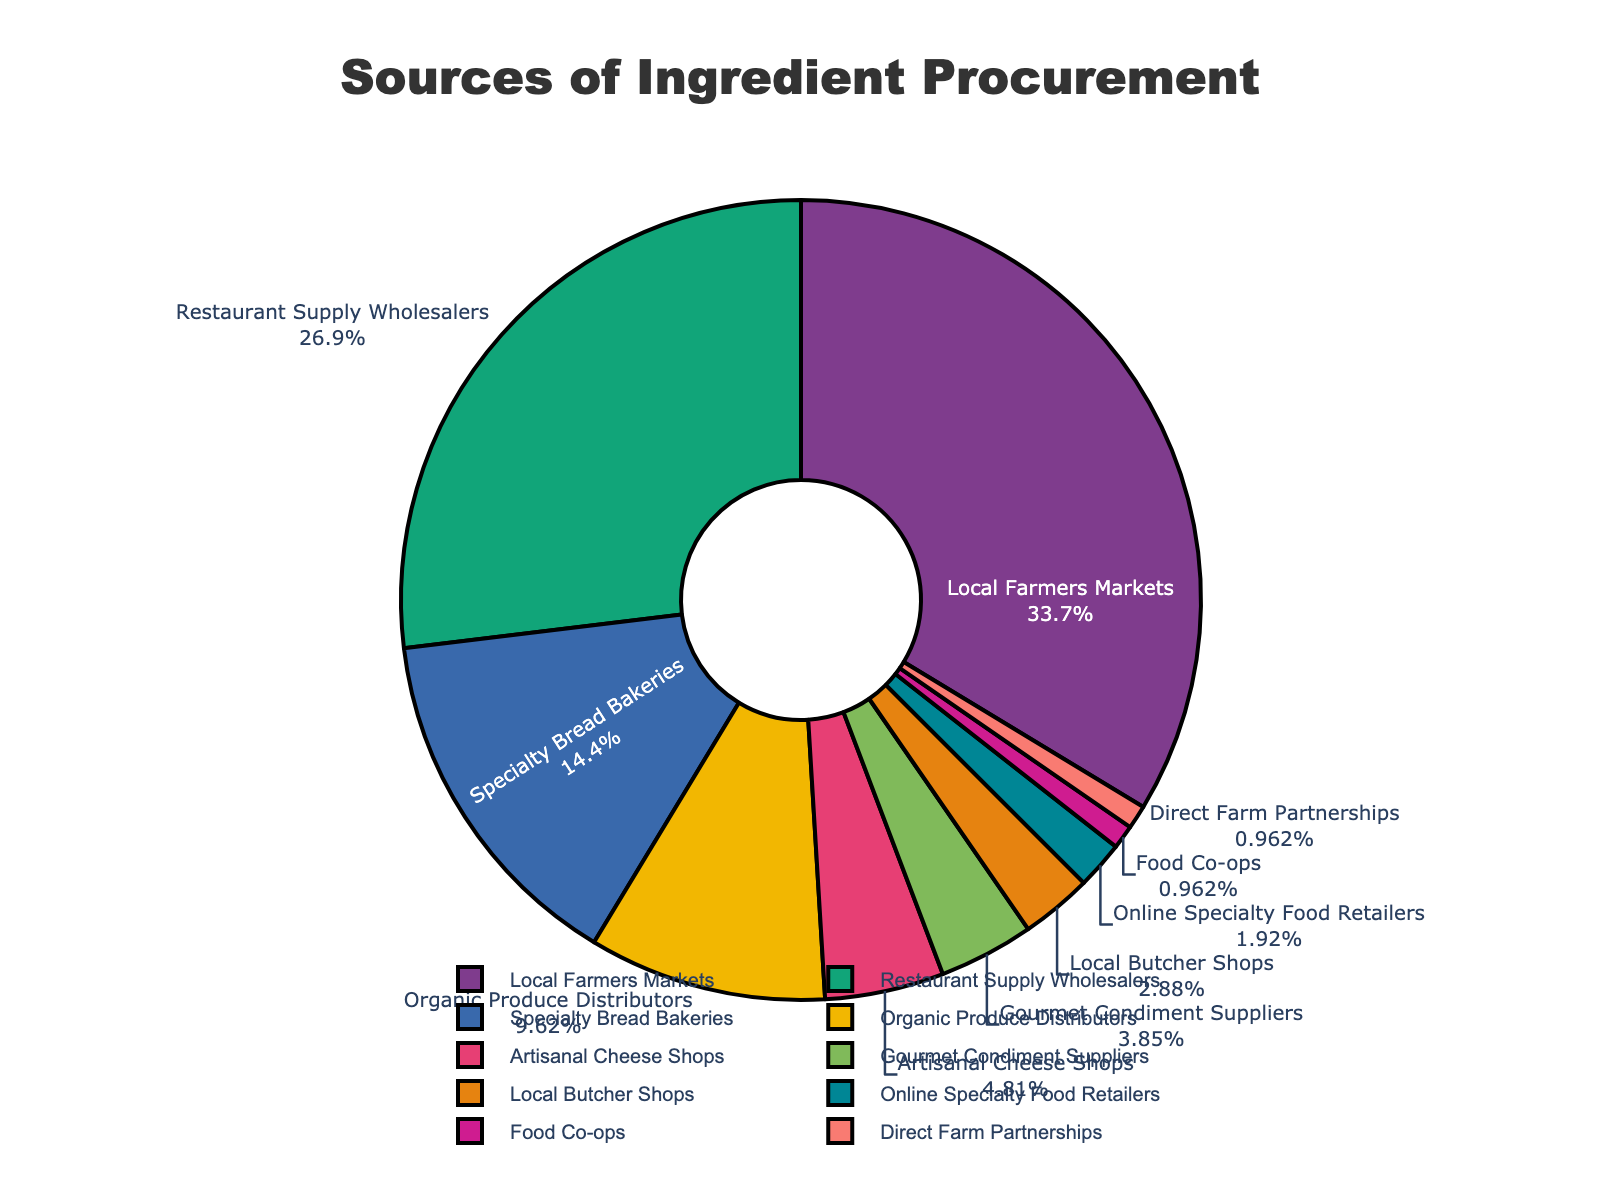Which supplier category provides the highest percentage of ingredients? By observing the size of the slices in the pie chart, the largest slice represents the supplier category with the highest percentage. The "Local Farmers Markets" category takes up the largest portion of the pie chart.
Answer: Local Farmers Markets What percentage of ingredients comes from Restaurant Supply Wholesalers and Specialty Bread Bakeries combined? Add the values associated with "Restaurant Supply Wholesalers" and "Specialty Bread Bakeries" in the figure: 28% (Restaurant Supply Wholesalers) + 15% (Specialty Bread Bakeries) = 43%.
Answer: 43% How does the percentage from Organic Produce Distributors compare to that from Artisanal Cheese Shops? Compare the values from the figure for "Organic Produce Distributors" (10%) and "Artisanal Cheese Shops" (5%). Organic Produce Distributors have a higher percentage.
Answer: 10% is higher than 5% Which supplier category provides the smallest percentage of ingredients? Look for the smallest slice in the pie chart. The segment labeled "Direct Farm Partnerships" and "Food Co-ops" are tied for the smallest share, each with 1%.
Answer: Direct Farm Partnerships and Food Co-ops What is the combined percentage of ingredients from Gourmet Condiment Suppliers, Local Butcher Shops, and Online Specialty Food Retailers? Sum the values associated with "Gourmet Condiment Suppliers" (4%), "Local Butcher Shops" (3%), and "Online Specialty Food Retailers" (2%): 4% + 3% + 2% = 9%.
Answer: 9% How much larger is the percentage from Local Farmers Markets compared to that from Organic Produce Distributors? Subtract the percentage of Organic Produce Distributors (10%) from the percentage of Local Farmers Markets (35%): 35% - 10% = 25%.
Answer: 25% What is the average percentage contribution of the top three supplier categories? The top three categories are "Local Farmers Markets" (35%), "Restaurant Supply Wholesalers" (28%), and "Specialty Bread Bakeries" (15%). Calculate the average: (35% + 28% + 15%) / 3 = 26%.
Answer: 26% Which category shows a percentage closest to 5%? The "Artisanal Cheese Shops" category is exactly at 5%, which matches the given percentage.
Answer: Artisanal Cheese Shops If you were to group the suppliers into two categories, those contributing less than 5% and those contributing 5% or more, which categories would be in each group? Identify categories based on their percentages: Categories contributing less than 5%: "Gourmet Condiment Suppliers" (4%), "Local Butcher Shops" (3%), "Online Specialty Food Retailers" (2%), "Food Co-ops" (1%), and "Direct Farm Partnerships" (1%). Categories contributing 5% or more: "Local Farmers Markets" (35%), "Restaurant Supply Wholesalers" (28%), "Specialty Bread Bakeries" (15%), "Organic Produce Distributors" (10%), and "Artisanal Cheese Shops" (5%).
Answer: Less than 5%: Gourmet Condiment Suppliers, Local Butcher Shops, Online Specialty Food Retailers, Food Co-ops, Direct Farm Partnerships; 5% or more: Local Farmers Markets, Restaurant Supply Wholesalers, Specialty Bread Bakeries, Organic Produce Distributors, Artisanal Cheese Shops How much of the total percentage is accounted for by Local Farmers Markets, Restaurant Supply Wholesalers, and Specialty Bread Bakeries together? Sum the values: Local Farmers Markets (35%), Restaurant Supply Wholesalers (28%), and Specialty Bread Bakeries (15%): 35% + 28% + 15% = 78%.
Answer: 78% 